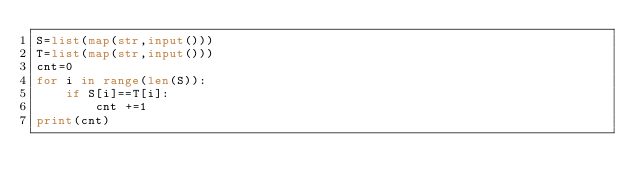<code> <loc_0><loc_0><loc_500><loc_500><_Python_>S=list(map(str,input()))
T=list(map(str,input()))
cnt=0
for i in range(len(S)):
    if S[i]==T[i]:
        cnt +=1
print(cnt)</code> 